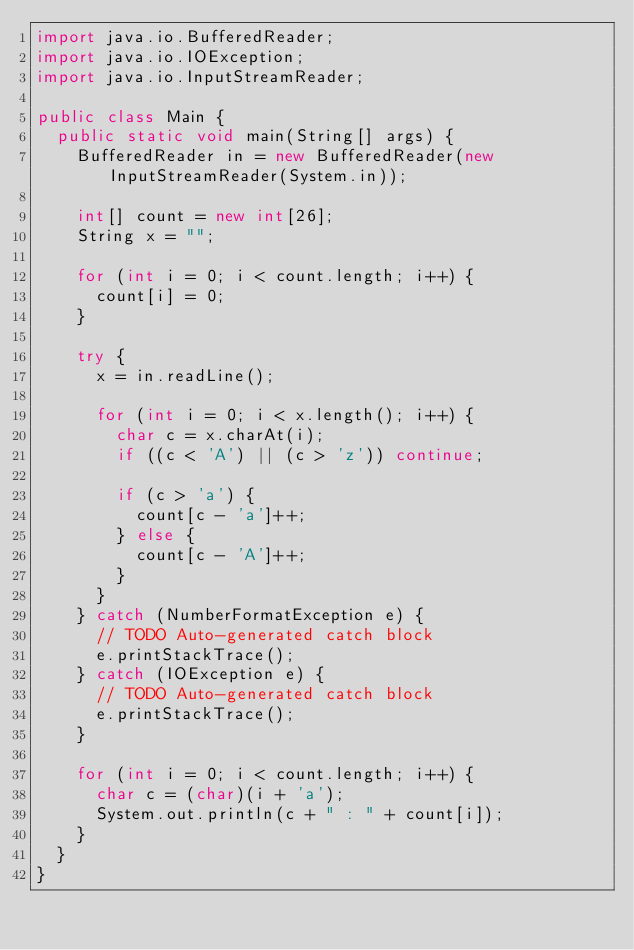Convert code to text. <code><loc_0><loc_0><loc_500><loc_500><_Java_>import java.io.BufferedReader;
import java.io.IOException;
import java.io.InputStreamReader;

public class Main {
	public static void main(String[] args) {
		BufferedReader in = new BufferedReader(new InputStreamReader(System.in));
    
		int[] count = new int[26];
		String x = "";
		
		for (int i = 0; i < count.length; i++) {
			count[i] = 0;
		}
		
		try {
			x = in.readLine();
			
			for (int i = 0; i < x.length(); i++) {
				char c = x.charAt(i);
				if ((c < 'A') || (c > 'z')) continue;
				
				if (c > 'a') {
					count[c - 'a']++;
				} else {
					count[c - 'A']++;
				}
			}
		} catch (NumberFormatException e) {
			// TODO Auto-generated catch block
			e.printStackTrace();
		} catch (IOException e) {
			// TODO Auto-generated catch block
			e.printStackTrace();
		}
		
		for (int i = 0; i < count.length; i++) {
			char c = (char)(i + 'a');
			System.out.println(c + " : " + count[i]);
		}
	}
}</code> 